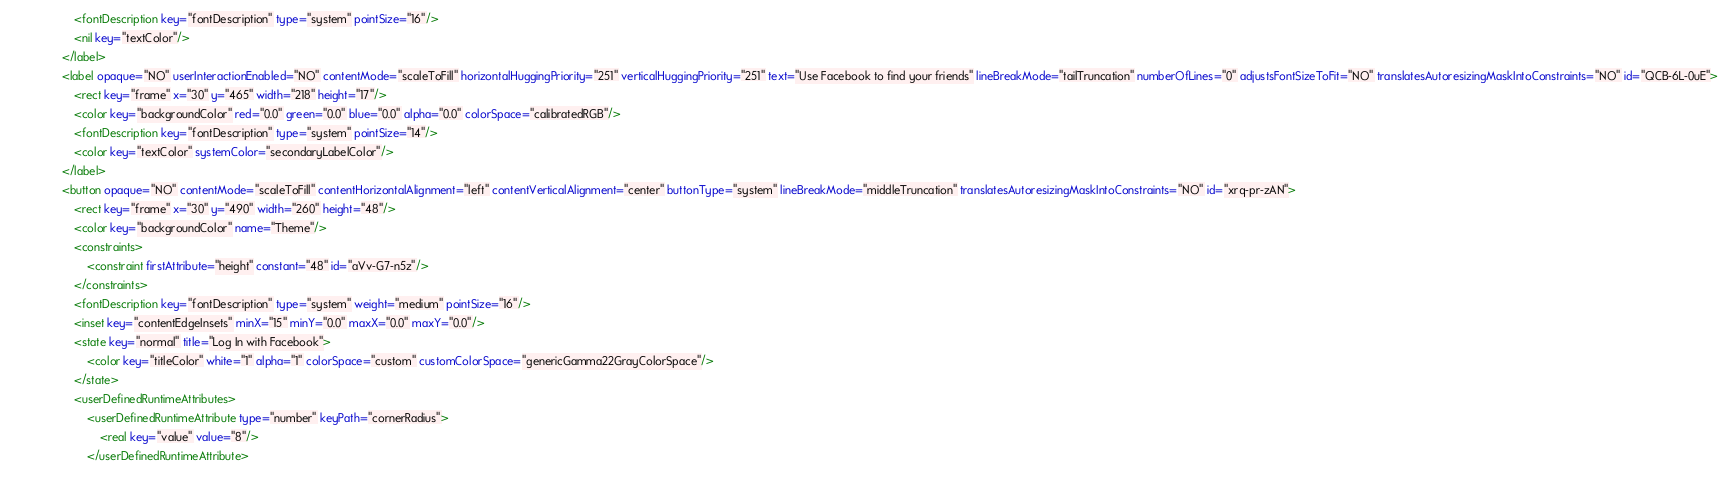<code> <loc_0><loc_0><loc_500><loc_500><_XML_>                    <fontDescription key="fontDescription" type="system" pointSize="16"/>
                    <nil key="textColor"/>
                </label>
                <label opaque="NO" userInteractionEnabled="NO" contentMode="scaleToFill" horizontalHuggingPriority="251" verticalHuggingPriority="251" text="Use Facebook to find your friends" lineBreakMode="tailTruncation" numberOfLines="0" adjustsFontSizeToFit="NO" translatesAutoresizingMaskIntoConstraints="NO" id="QCB-6L-0uE">
                    <rect key="frame" x="30" y="465" width="218" height="17"/>
                    <color key="backgroundColor" red="0.0" green="0.0" blue="0.0" alpha="0.0" colorSpace="calibratedRGB"/>
                    <fontDescription key="fontDescription" type="system" pointSize="14"/>
                    <color key="textColor" systemColor="secondaryLabelColor"/>
                </label>
                <button opaque="NO" contentMode="scaleToFill" contentHorizontalAlignment="left" contentVerticalAlignment="center" buttonType="system" lineBreakMode="middleTruncation" translatesAutoresizingMaskIntoConstraints="NO" id="xrq-pr-zAN">
                    <rect key="frame" x="30" y="490" width="260" height="48"/>
                    <color key="backgroundColor" name="Theme"/>
                    <constraints>
                        <constraint firstAttribute="height" constant="48" id="aVv-G7-n5z"/>
                    </constraints>
                    <fontDescription key="fontDescription" type="system" weight="medium" pointSize="16"/>
                    <inset key="contentEdgeInsets" minX="15" minY="0.0" maxX="0.0" maxY="0.0"/>
                    <state key="normal" title="Log In with Facebook">
                        <color key="titleColor" white="1" alpha="1" colorSpace="custom" customColorSpace="genericGamma22GrayColorSpace"/>
                    </state>
                    <userDefinedRuntimeAttributes>
                        <userDefinedRuntimeAttribute type="number" keyPath="cornerRadius">
                            <real key="value" value="8"/>
                        </userDefinedRuntimeAttribute></code> 